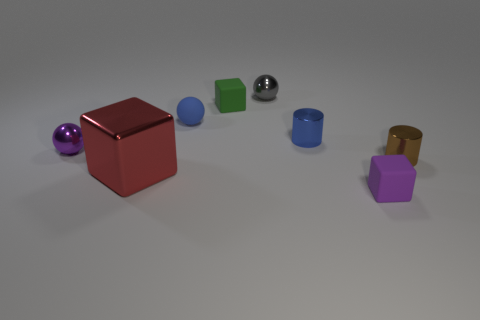Subtract all metal balls. How many balls are left? 1 Subtract 1 balls. How many balls are left? 2 Add 2 big green cylinders. How many objects exist? 10 Subtract all cylinders. How many objects are left? 6 Subtract all brown balls. Subtract all blue cylinders. How many balls are left? 3 Subtract all large cyan shiny balls. Subtract all big red shiny blocks. How many objects are left? 7 Add 1 tiny blue shiny cylinders. How many tiny blue shiny cylinders are left? 2 Add 2 red cubes. How many red cubes exist? 3 Subtract 0 green cylinders. How many objects are left? 8 